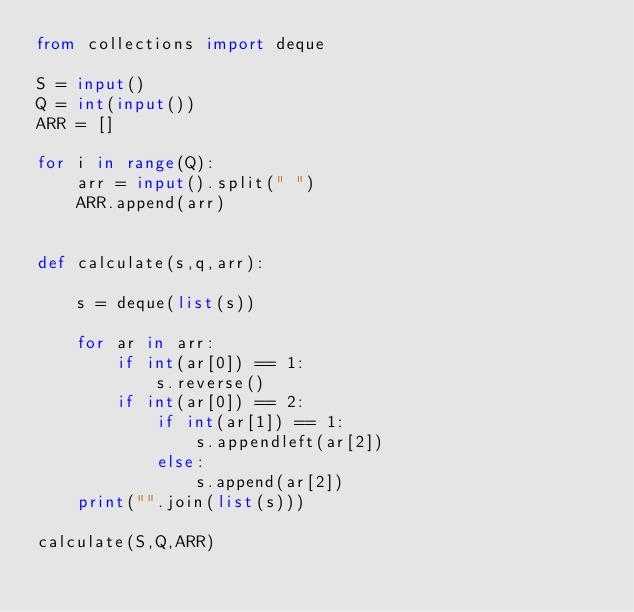Convert code to text. <code><loc_0><loc_0><loc_500><loc_500><_Python_>from collections import deque

S = input()
Q = int(input())
ARR = []

for i in range(Q):
    arr = input().split(" ")
    ARR.append(arr)


def calculate(s,q,arr):

    s = deque(list(s))

    for ar in arr:
        if int(ar[0]) == 1:
            s.reverse()
        if int(ar[0]) == 2:
            if int(ar[1]) == 1:
                s.appendleft(ar[2])
            else:
                s.append(ar[2])
    print("".join(list(s)))

calculate(S,Q,ARR)</code> 